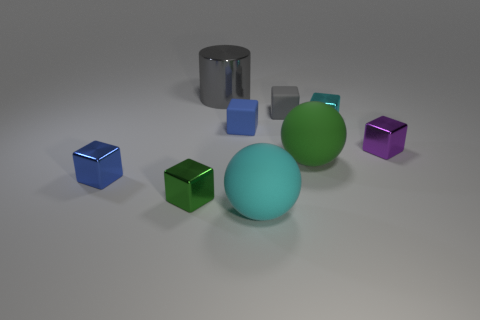Subtract all green cubes. How many cubes are left? 5 Subtract all cyan shiny cubes. How many cubes are left? 5 Add 1 gray shiny cylinders. How many objects exist? 10 Subtract all green cubes. Subtract all gray spheres. How many cubes are left? 5 Subtract all cylinders. How many objects are left? 8 Subtract all tiny red metallic cylinders. Subtract all large gray metallic objects. How many objects are left? 8 Add 2 big cyan balls. How many big cyan balls are left? 3 Add 6 gray matte things. How many gray matte things exist? 7 Subtract 1 blue cubes. How many objects are left? 8 